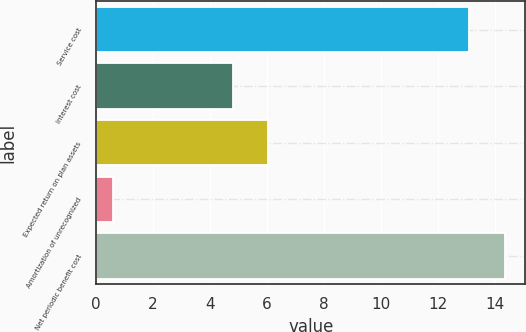Convert chart to OTSL. <chart><loc_0><loc_0><loc_500><loc_500><bar_chart><fcel>Service cost<fcel>Interest cost<fcel>Expected return on plan assets<fcel>Amortization of unrecognized<fcel>Net periodic benefit cost<nl><fcel>13.1<fcel>4.8<fcel>6.05<fcel>0.6<fcel>14.35<nl></chart> 